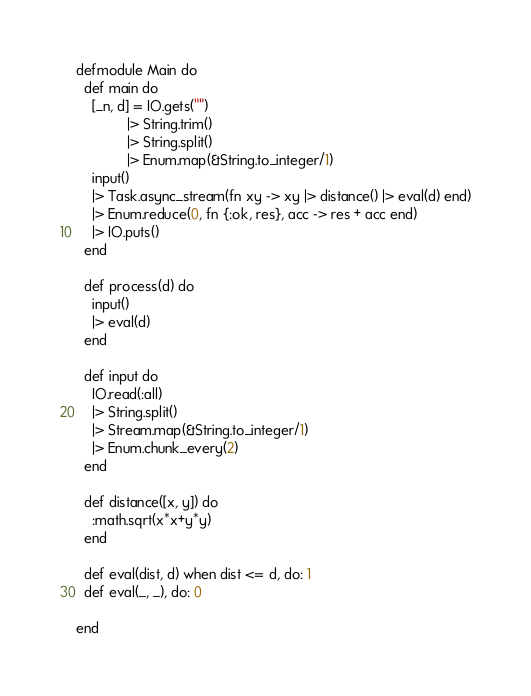Convert code to text. <code><loc_0><loc_0><loc_500><loc_500><_Elixir_>defmodule Main do
  def main do
    [_n, d] = IO.gets("")
             |> String.trim()
             |> String.split()
             |> Enum.map(&String.to_integer/1)
    input()
    |> Task.async_stream(fn xy -> xy |> distance() |> eval(d) end)
    |> Enum.reduce(0, fn {:ok, res}, acc -> res + acc end)
    |> IO.puts()
  end

  def process(d) do
    input()
    |> eval(d)
  end

  def input do
    IO.read(:all)
    |> String.split()
    |> Stream.map(&String.to_integer/1)
    |> Enum.chunk_every(2)
  end

  def distance([x, y]) do
    :math.sqrt(x*x+y*y)
  end

  def eval(dist, d) when dist <= d, do: 1
  def eval(_, _), do: 0

end
</code> 